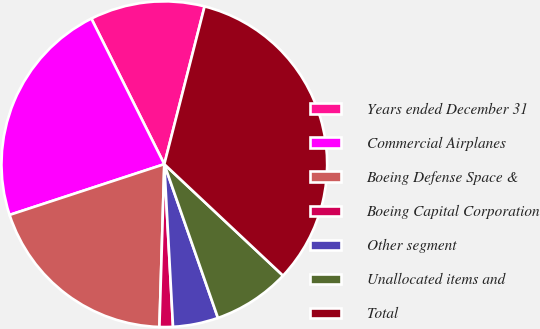Convert chart. <chart><loc_0><loc_0><loc_500><loc_500><pie_chart><fcel>Years ended December 31<fcel>Commercial Airplanes<fcel>Boeing Defense Space &<fcel>Boeing Capital Corporation<fcel>Other segment<fcel>Unallocated items and<fcel>Total<nl><fcel>11.37%<fcel>22.65%<fcel>19.48%<fcel>1.33%<fcel>4.49%<fcel>7.66%<fcel>33.02%<nl></chart> 